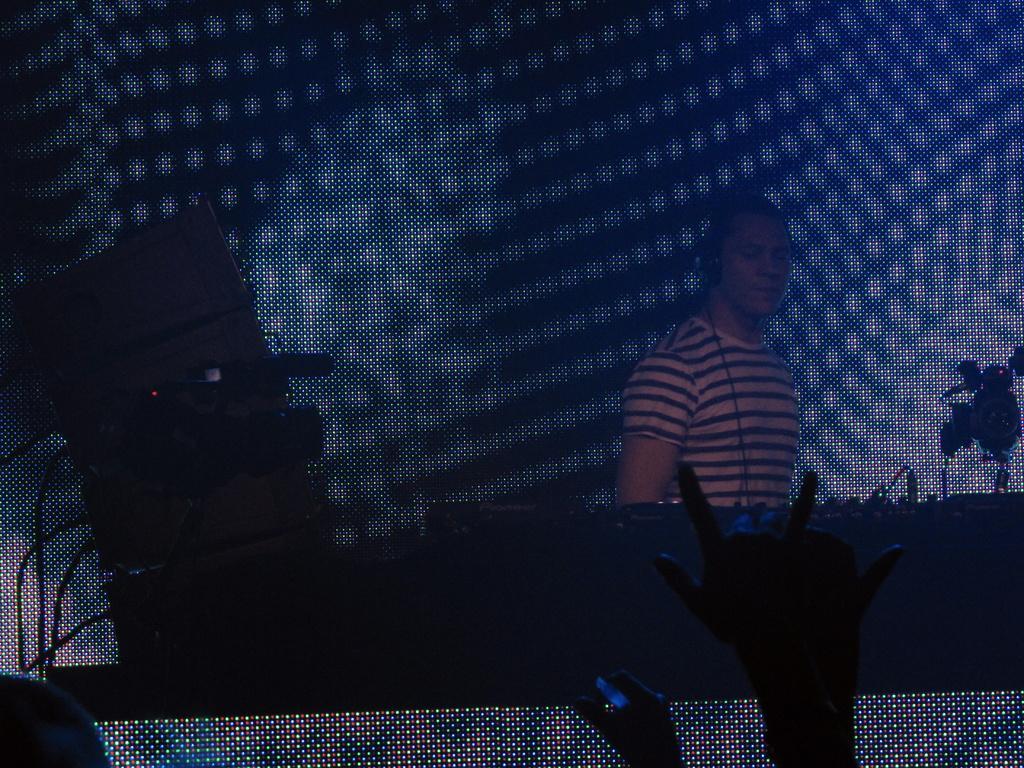In one or two sentences, can you explain what this image depicts? This image is taken in a concert. At the bottom of the image there are a few people. In this image the background is a little blurred. In the middle of the image a man is standing and there is a table with a few things on it. 